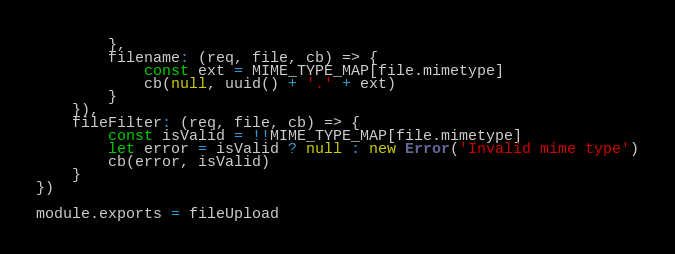<code> <loc_0><loc_0><loc_500><loc_500><_JavaScript_>        },
        filename: (req, file, cb) => {
            const ext = MIME_TYPE_MAP[file.mimetype]
            cb(null, uuid() + '.' + ext)
        }
    }),
    fileFilter: (req, file, cb) => {
        const isValid = !!MIME_TYPE_MAP[file.mimetype]
        let error = isValid ? null : new Error('Invalid mime type')
        cb(error, isValid)
    }
})

module.exports = fileUpload</code> 